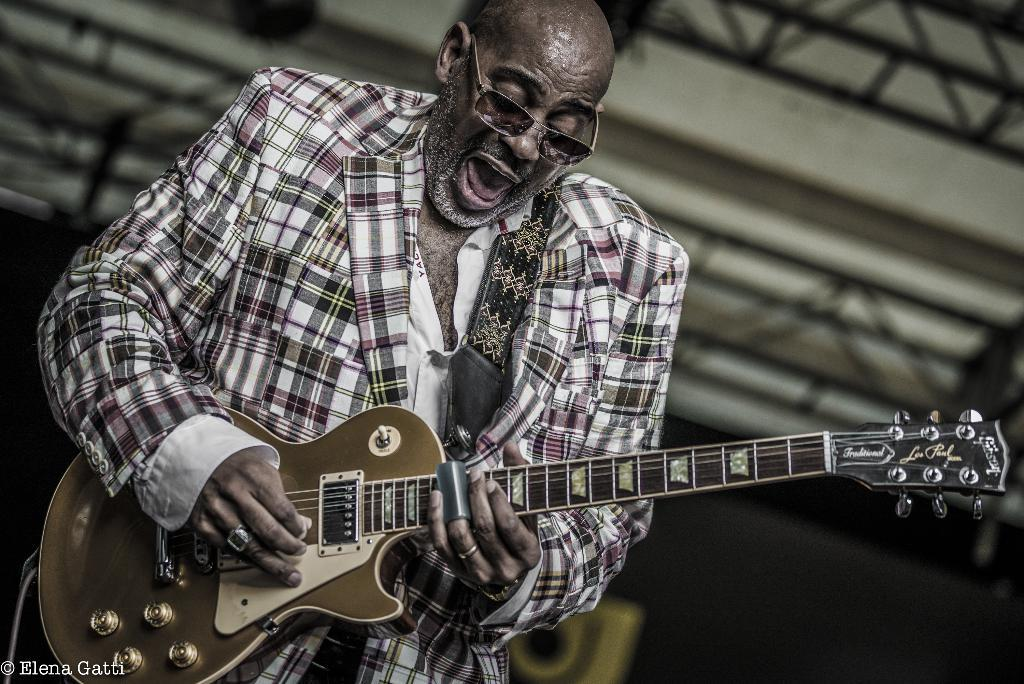What is the man in the image doing? The man is holding a guitar and singing something. What object is the man holding in the image? The man is holding a guitar. Can you describe the man's appearance in the image? The man is wearing glasses (specs) in the image. What type of celery is the man eating in the image? There is no celery present in the image. Is the man playing volleyball in the image? No, the man is not playing volleyball in the image; he is holding a guitar and singing. 